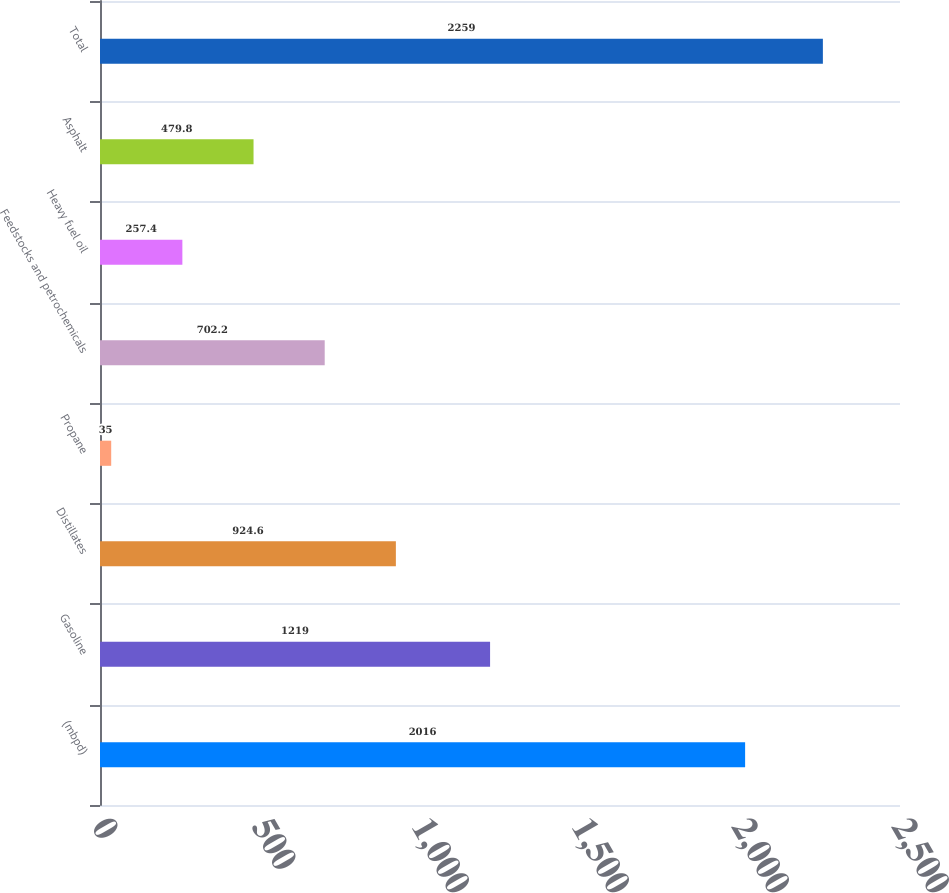Convert chart. <chart><loc_0><loc_0><loc_500><loc_500><bar_chart><fcel>(mbpd)<fcel>Gasoline<fcel>Distillates<fcel>Propane<fcel>Feedstocks and petrochemicals<fcel>Heavy fuel oil<fcel>Asphalt<fcel>Total<nl><fcel>2016<fcel>1219<fcel>924.6<fcel>35<fcel>702.2<fcel>257.4<fcel>479.8<fcel>2259<nl></chart> 